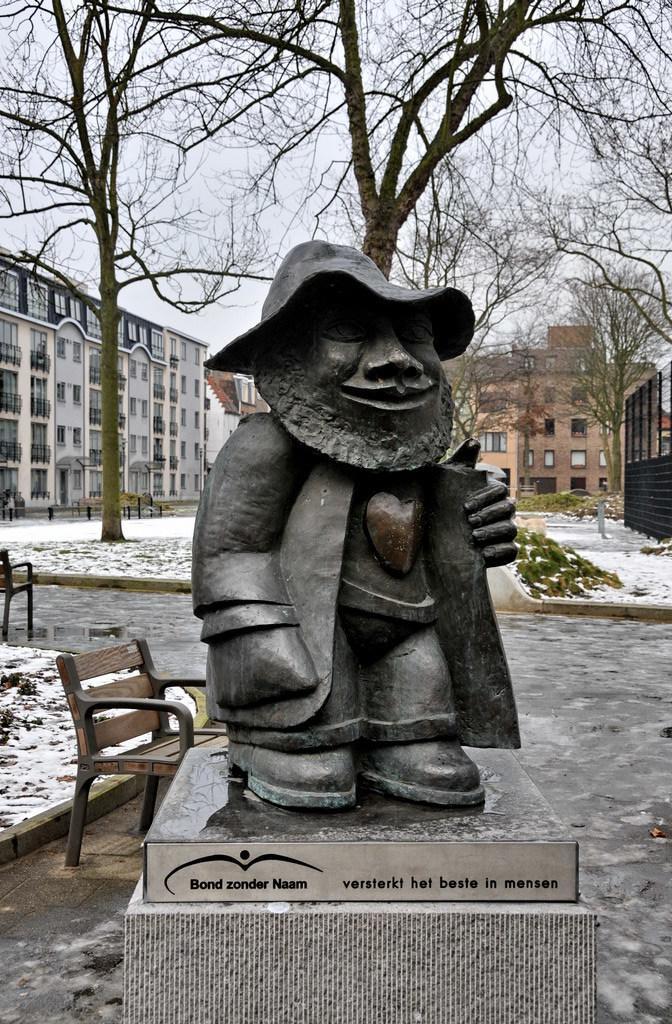In one or two sentences, can you explain what this image depicts? This is an outside view. Here I can see a statue. Beside this there is a bench. In the background there are buildings and the trees. 